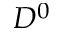Convert formula to latex. <formula><loc_0><loc_0><loc_500><loc_500>D ^ { 0 }</formula> 